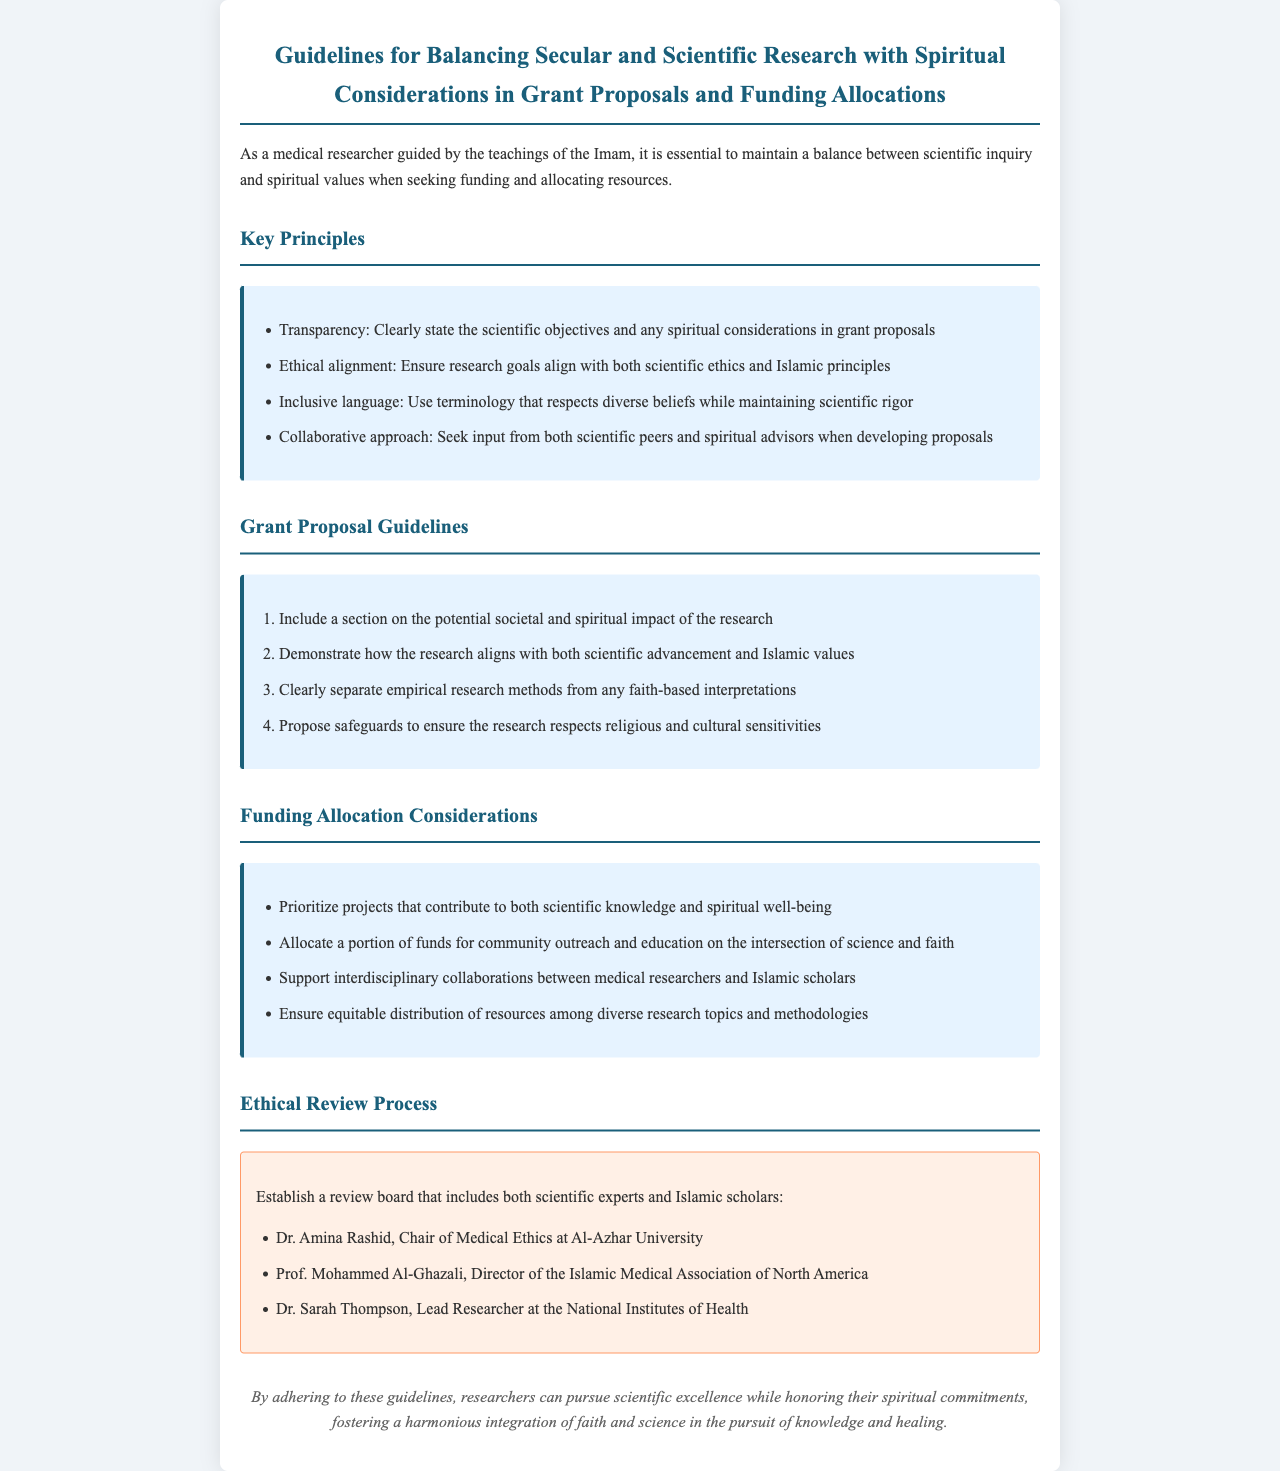What is the title of the document? The title is clearly stated at the top of the document.
Answer: Guidelines for Balancing Secular and Scientific Research with Spiritual Considerations in Grant Proposals and Funding Allocations Who is the chair of the Ethical Review Process? The document lists the members of the review board, including the chair.
Answer: Dr. Amina Rashid What are the four key principles mentioned in the guidelines? The document outlines key principles in a specific section.
Answer: Transparency, Ethical alignment, Inclusive language, Collaborative approach How many grant proposal guidelines are provided? The document enumerates the guidelines in an ordered list.
Answer: Four What type of projects should be prioritized in funding allocations? The document specifies funding allocation considerations in a list.
Answer: Projects that contribute to both scientific knowledge and spiritual well-being Who is one of the members from the Islamic Medical Association of North America? The document names members of the ethical review board.
Answer: Prof. Mohammed Al-Ghazali What section addresses the potential societal and spiritual impact? The guidelines clearly state this requirement in the proposal section.
Answer: Grant Proposal Guidelines How are resources suggested to be distributed? The document discusses equitable distribution in funding allocation considerations.
Answer: Equitable distribution among diverse research topics and methodologies What is the primary purpose of these guidelines? The document states the overall aim of following these guidelines.
Answer: To pursue scientific excellence while honoring spiritual commitments 